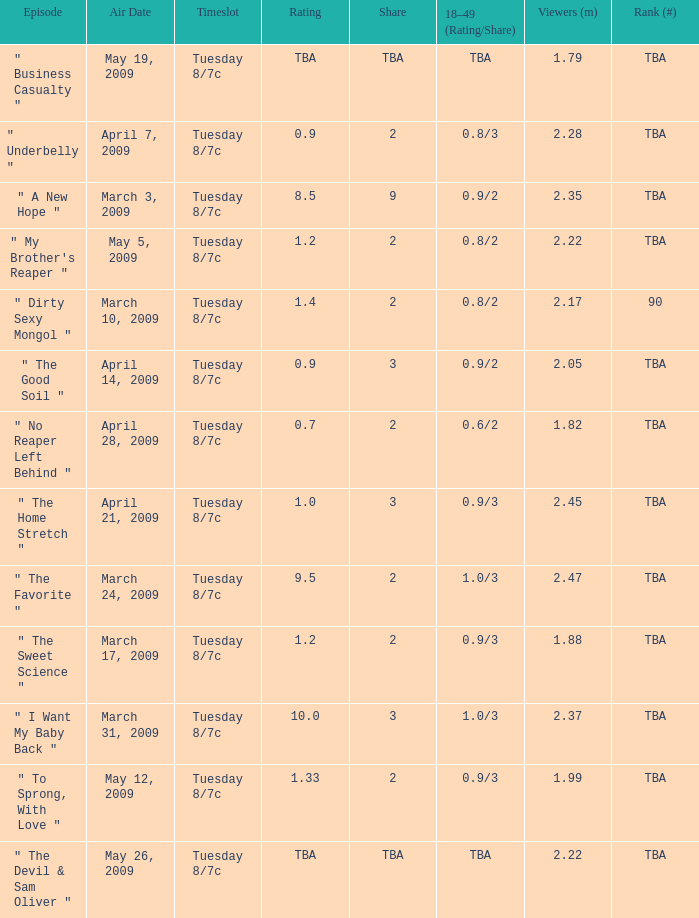What is the rating of the show ranked tba, aired on April 21, 2009? 1.0. 